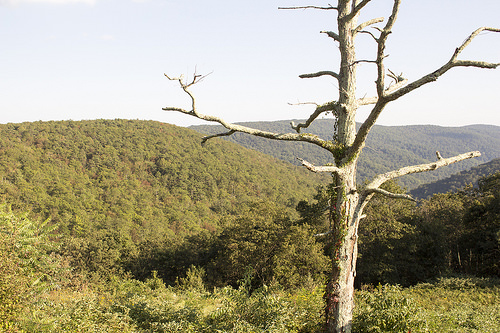<image>
Is there a tree to the left of the mountain? No. The tree is not to the left of the mountain. From this viewpoint, they have a different horizontal relationship. 